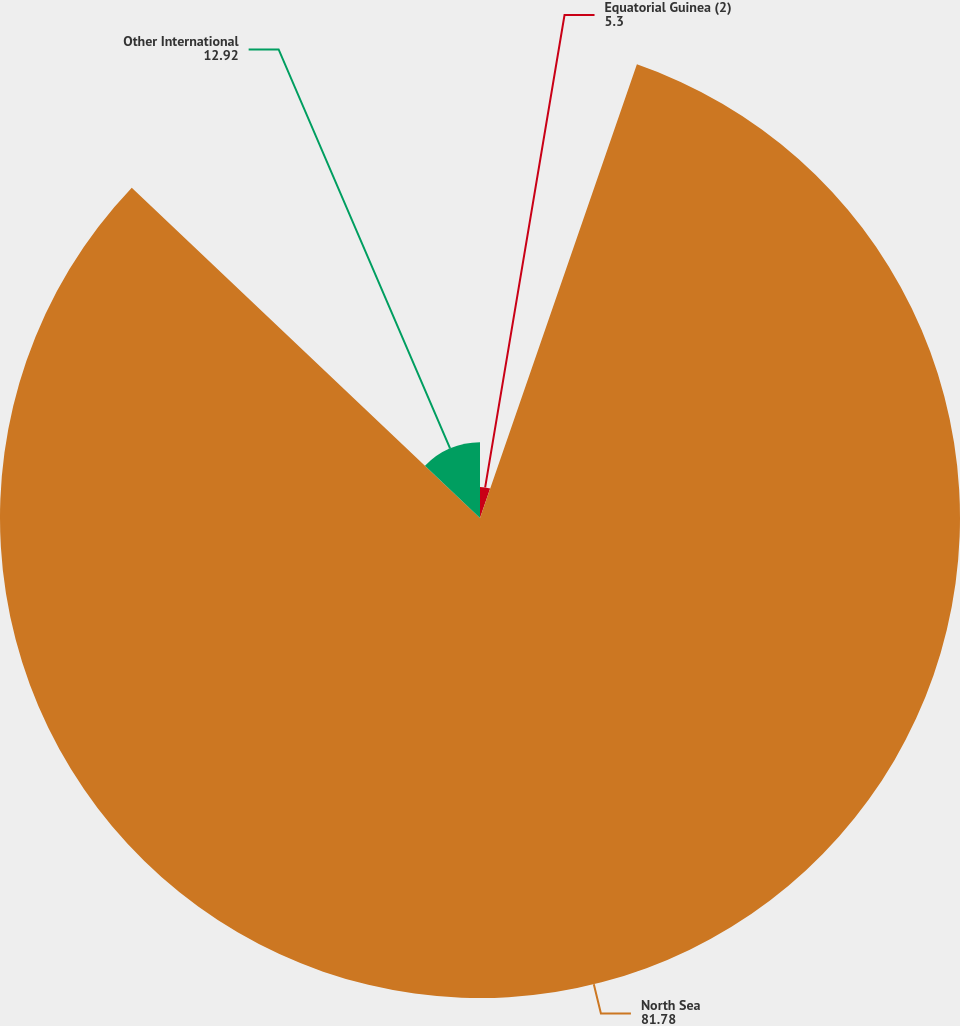Convert chart. <chart><loc_0><loc_0><loc_500><loc_500><pie_chart><fcel>Equatorial Guinea (2)<fcel>North Sea<fcel>Other International<nl><fcel>5.3%<fcel>81.78%<fcel>12.92%<nl></chart> 